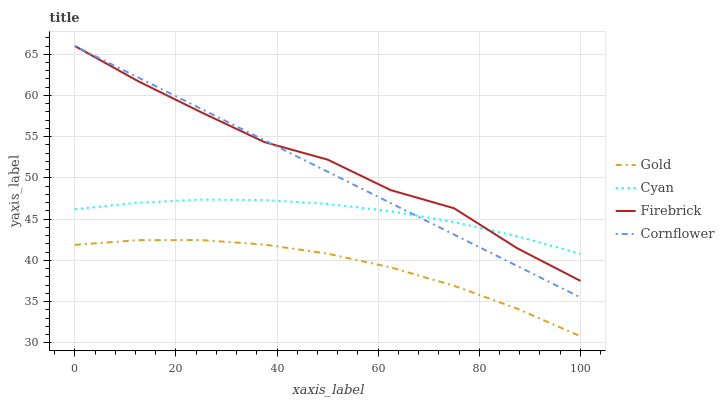Does Gold have the minimum area under the curve?
Answer yes or no. Yes. Does Firebrick have the maximum area under the curve?
Answer yes or no. Yes. Does Firebrick have the minimum area under the curve?
Answer yes or no. No. Does Gold have the maximum area under the curve?
Answer yes or no. No. Is Cornflower the smoothest?
Answer yes or no. Yes. Is Firebrick the roughest?
Answer yes or no. Yes. Is Gold the smoothest?
Answer yes or no. No. Is Gold the roughest?
Answer yes or no. No. Does Gold have the lowest value?
Answer yes or no. Yes. Does Firebrick have the lowest value?
Answer yes or no. No. Does Cornflower have the highest value?
Answer yes or no. Yes. Does Gold have the highest value?
Answer yes or no. No. Is Gold less than Cornflower?
Answer yes or no. Yes. Is Cornflower greater than Gold?
Answer yes or no. Yes. Does Cyan intersect Firebrick?
Answer yes or no. Yes. Is Cyan less than Firebrick?
Answer yes or no. No. Is Cyan greater than Firebrick?
Answer yes or no. No. Does Gold intersect Cornflower?
Answer yes or no. No. 